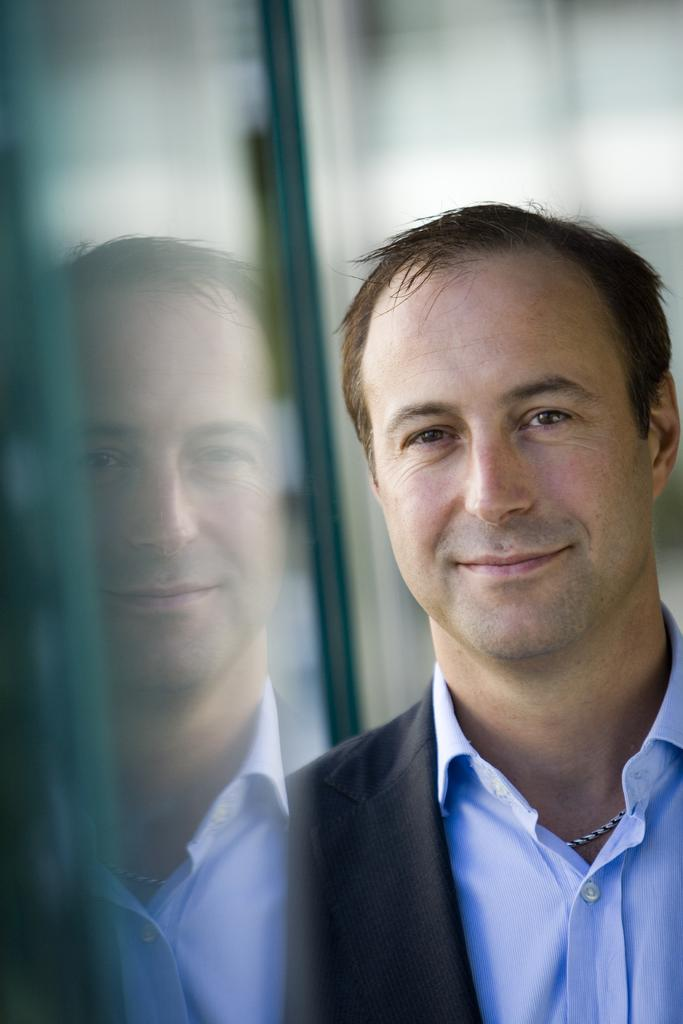What is the person wearing on the right side of the image? The person is wearing a blue color shirt on the right side of the image. What is the person's facial expression in the image? The person is smiling in the image. What object can be seen on the left side of the image? There is a glass on the left side of the image. Can you describe the background of the image? The background of the image is blurred. What type of leather material is visible in the image? There is no leather material present in the image. What historical event is being depicted in the image? The image does not depict any historical event; it features a person in a blue color shirt, a smiling expression, a glass, and a blurred background. 